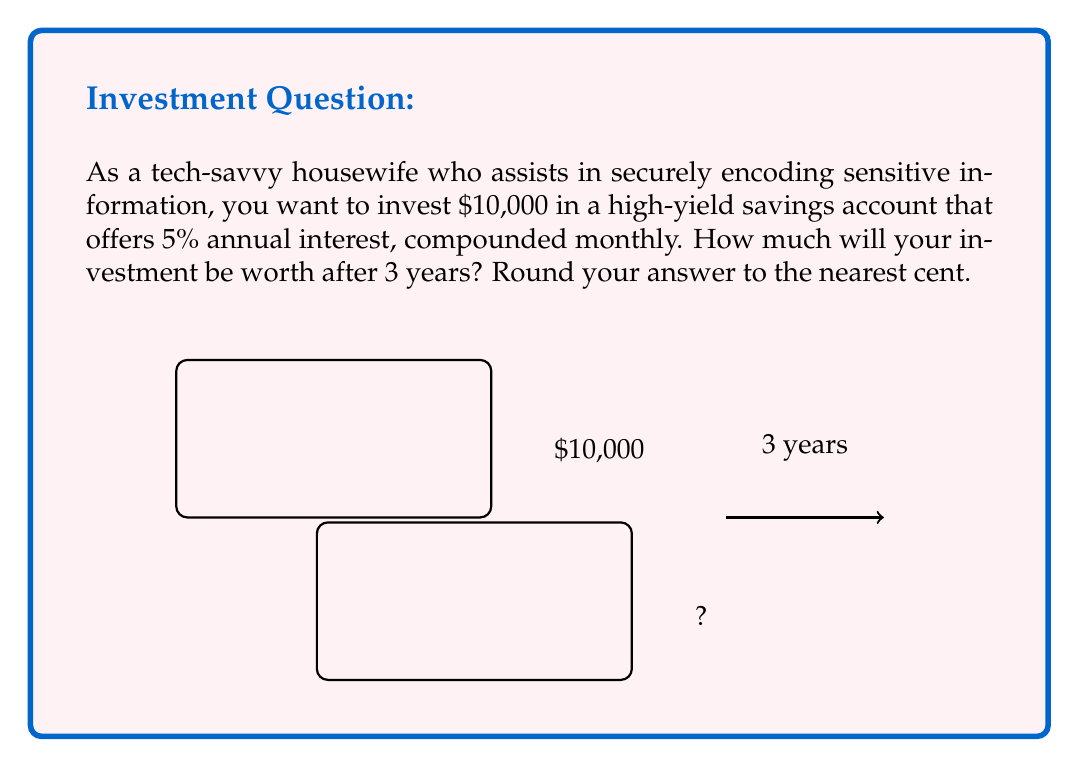Teach me how to tackle this problem. To solve this problem, we'll use the compound interest formula:

$$A = P(1 + \frac{r}{n})^{nt}$$

Where:
$A$ = Final amount
$P$ = Principal (initial investment)
$r$ = Annual interest rate (as a decimal)
$n$ = Number of times interest is compounded per year
$t$ = Number of years

Given:
$P = 10,000$
$r = 0.05$ (5% expressed as a decimal)
$n = 12$ (compounded monthly)
$t = 3$ years

Let's plug these values into the formula:

$$A = 10,000(1 + \frac{0.05}{12})^{12 * 3}$$

$$A = 10,000(1 + 0.004167)^{36}$$

$$A = 10,000(1.004167)^{36}$$

Using a calculator or spreadsheet to compute this:

$$A = 10,000 * 1.161616$$

$$A = 11,616.16$$

Rounding to the nearest cent gives us $11,616.16.
Answer: $11,616.16 